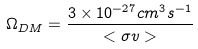Convert formula to latex. <formula><loc_0><loc_0><loc_500><loc_500>\Omega _ { D M } = \frac { 3 \times 1 0 ^ { - 2 7 } c m ^ { 3 } s ^ { - 1 } } { < \sigma v > }</formula> 